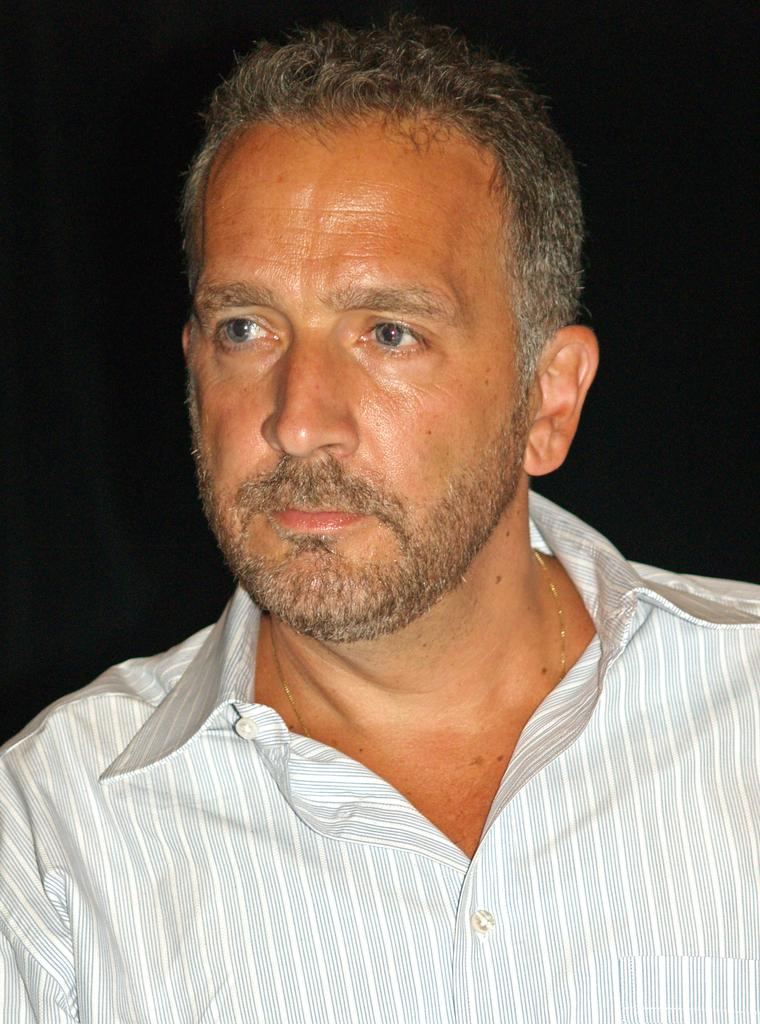Who is present in the image? There is a man in the picture. What is the man wearing? The man is wearing a white shirt. In which direction is the man looking? The man is looking to the left. What is the color of the background in the image? There is a black background in the image. What type of pets does the man have in the image? There are no pets visible in the image. What is the man doing with his head in the image? The man's head is not performing any specific action in the image; he is simply looking to the left. 